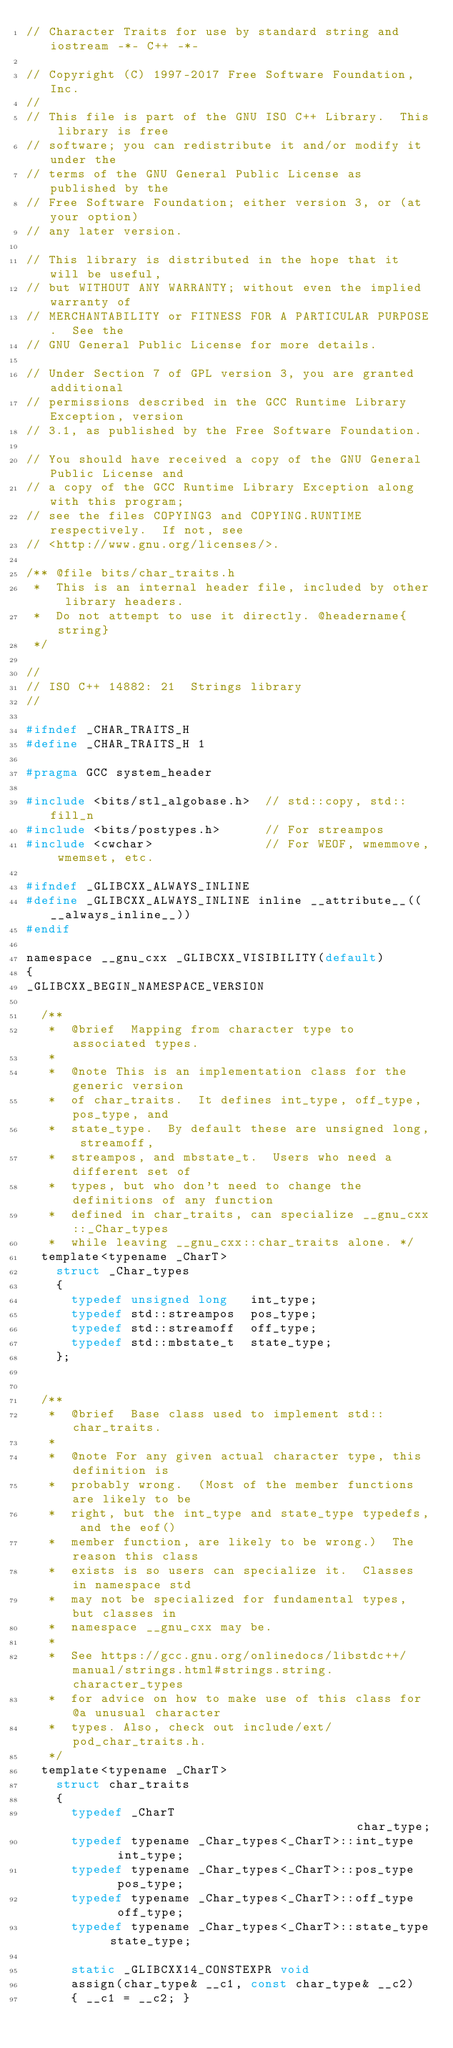Convert code to text. <code><loc_0><loc_0><loc_500><loc_500><_C_>// Character Traits for use by standard string and iostream -*- C++ -*-

// Copyright (C) 1997-2017 Free Software Foundation, Inc.
//
// This file is part of the GNU ISO C++ Library.  This library is free
// software; you can redistribute it and/or modify it under the
// terms of the GNU General Public License as published by the
// Free Software Foundation; either version 3, or (at your option)
// any later version.

// This library is distributed in the hope that it will be useful,
// but WITHOUT ANY WARRANTY; without even the implied warranty of
// MERCHANTABILITY or FITNESS FOR A PARTICULAR PURPOSE.  See the
// GNU General Public License for more details.

// Under Section 7 of GPL version 3, you are granted additional
// permissions described in the GCC Runtime Library Exception, version
// 3.1, as published by the Free Software Foundation.

// You should have received a copy of the GNU General Public License and
// a copy of the GCC Runtime Library Exception along with this program;
// see the files COPYING3 and COPYING.RUNTIME respectively.  If not, see
// <http://www.gnu.org/licenses/>.

/** @file bits/char_traits.h
 *  This is an internal header file, included by other library headers.
 *  Do not attempt to use it directly. @headername{string}
 */

//
// ISO C++ 14882: 21  Strings library
//

#ifndef _CHAR_TRAITS_H
#define _CHAR_TRAITS_H 1

#pragma GCC system_header

#include <bits/stl_algobase.h>  // std::copy, std::fill_n
#include <bits/postypes.h>      // For streampos
#include <cwchar>               // For WEOF, wmemmove, wmemset, etc.

#ifndef _GLIBCXX_ALWAYS_INLINE
#define _GLIBCXX_ALWAYS_INLINE inline __attribute__((__always_inline__))
#endif

namespace __gnu_cxx _GLIBCXX_VISIBILITY(default)
{
_GLIBCXX_BEGIN_NAMESPACE_VERSION

  /**
   *  @brief  Mapping from character type to associated types.
   *
   *  @note This is an implementation class for the generic version
   *  of char_traits.  It defines int_type, off_type, pos_type, and
   *  state_type.  By default these are unsigned long, streamoff,
   *  streampos, and mbstate_t.  Users who need a different set of
   *  types, but who don't need to change the definitions of any function
   *  defined in char_traits, can specialize __gnu_cxx::_Char_types
   *  while leaving __gnu_cxx::char_traits alone. */
  template<typename _CharT>
    struct _Char_types
    {
      typedef unsigned long   int_type;
      typedef std::streampos  pos_type;
      typedef std::streamoff  off_type;
      typedef std::mbstate_t  state_type;
    };


  /**
   *  @brief  Base class used to implement std::char_traits.
   *
   *  @note For any given actual character type, this definition is
   *  probably wrong.  (Most of the member functions are likely to be
   *  right, but the int_type and state_type typedefs, and the eof()
   *  member function, are likely to be wrong.)  The reason this class
   *  exists is so users can specialize it.  Classes in namespace std
   *  may not be specialized for fundamental types, but classes in
   *  namespace __gnu_cxx may be.
   *
   *  See https://gcc.gnu.org/onlinedocs/libstdc++/manual/strings.html#strings.string.character_types
   *  for advice on how to make use of this class for @a unusual character
   *  types. Also, check out include/ext/pod_char_traits.h.  
   */
  template<typename _CharT>
    struct char_traits
    {
      typedef _CharT                                    char_type;
      typedef typename _Char_types<_CharT>::int_type    int_type;
      typedef typename _Char_types<_CharT>::pos_type    pos_type;
      typedef typename _Char_types<_CharT>::off_type    off_type;
      typedef typename _Char_types<_CharT>::state_type  state_type;

      static _GLIBCXX14_CONSTEXPR void
      assign(char_type& __c1, const char_type& __c2)
      { __c1 = __c2; }
</code> 